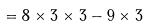<formula> <loc_0><loc_0><loc_500><loc_500>= 8 \times 3 \times 3 - 9 \times 3</formula> 